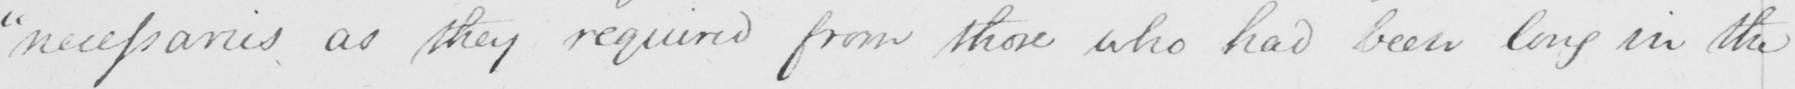Can you read and transcribe this handwriting? " necessaries as they required from those who had been long in the 